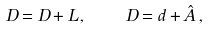<formula> <loc_0><loc_0><loc_500><loc_500>\ D = D + L \, , \quad D = d + \hat { A } \, ,</formula> 